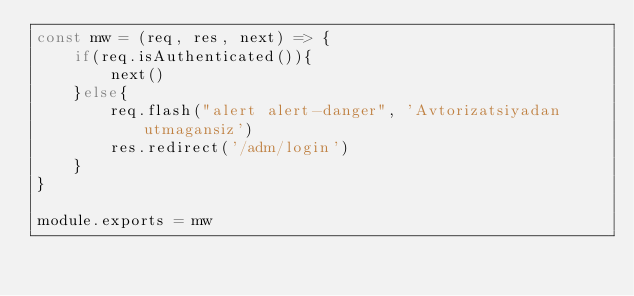<code> <loc_0><loc_0><loc_500><loc_500><_JavaScript_>const mw = (req, res, next) => {
    if(req.isAuthenticated()){
        next()
    }else{
        req.flash("alert alert-danger", 'Avtorizatsiyadan utmagansiz')
        res.redirect('/adm/login')
    }
}

module.exports = mw</code> 